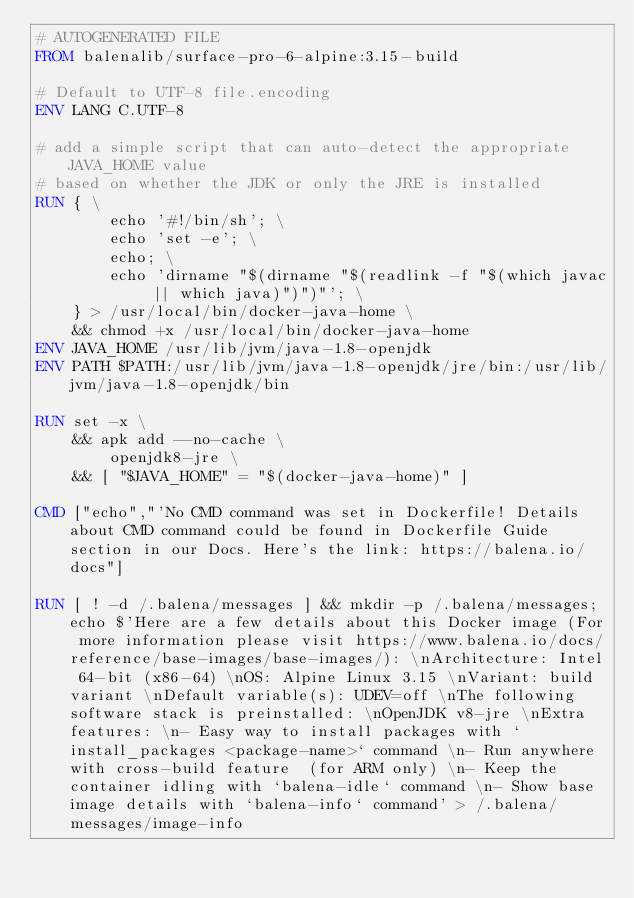Convert code to text. <code><loc_0><loc_0><loc_500><loc_500><_Dockerfile_># AUTOGENERATED FILE
FROM balenalib/surface-pro-6-alpine:3.15-build

# Default to UTF-8 file.encoding
ENV LANG C.UTF-8

# add a simple script that can auto-detect the appropriate JAVA_HOME value
# based on whether the JDK or only the JRE is installed
RUN { \
		echo '#!/bin/sh'; \
		echo 'set -e'; \
		echo; \
		echo 'dirname "$(dirname "$(readlink -f "$(which javac || which java)")")"'; \
	} > /usr/local/bin/docker-java-home \
	&& chmod +x /usr/local/bin/docker-java-home
ENV JAVA_HOME /usr/lib/jvm/java-1.8-openjdk
ENV PATH $PATH:/usr/lib/jvm/java-1.8-openjdk/jre/bin:/usr/lib/jvm/java-1.8-openjdk/bin

RUN set -x \
	&& apk add --no-cache \
		openjdk8-jre \
	&& [ "$JAVA_HOME" = "$(docker-java-home)" ]

CMD ["echo","'No CMD command was set in Dockerfile! Details about CMD command could be found in Dockerfile Guide section in our Docs. Here's the link: https://balena.io/docs"]

RUN [ ! -d /.balena/messages ] && mkdir -p /.balena/messages; echo $'Here are a few details about this Docker image (For more information please visit https://www.balena.io/docs/reference/base-images/base-images/): \nArchitecture: Intel 64-bit (x86-64) \nOS: Alpine Linux 3.15 \nVariant: build variant \nDefault variable(s): UDEV=off \nThe following software stack is preinstalled: \nOpenJDK v8-jre \nExtra features: \n- Easy way to install packages with `install_packages <package-name>` command \n- Run anywhere with cross-build feature  (for ARM only) \n- Keep the container idling with `balena-idle` command \n- Show base image details with `balena-info` command' > /.balena/messages/image-info</code> 